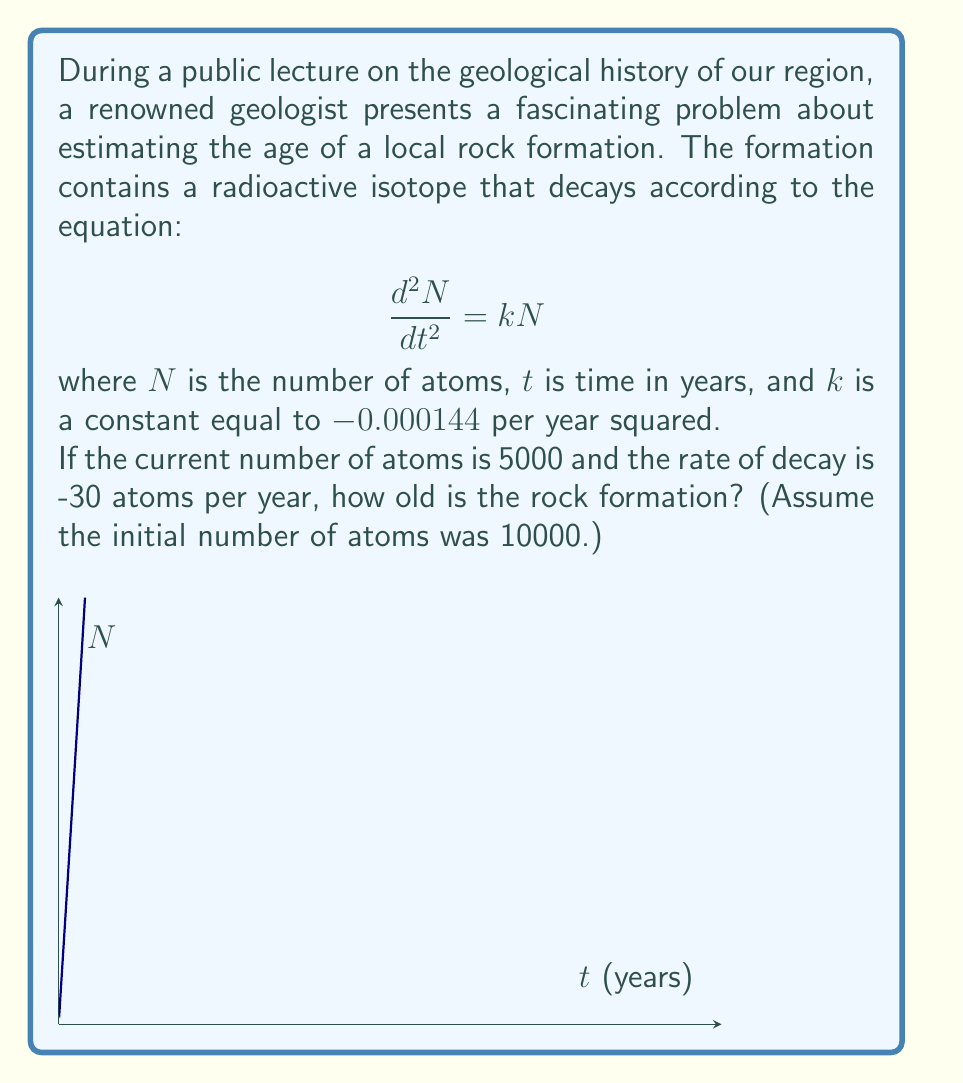Show me your answer to this math problem. Let's approach this step-by-step:

1) The general solution to the given differential equation is:
   $$N = Ae^{\sqrt{k}t} + Be^{-\sqrt{k}t}$$

2) We know that $k = -0.000144$, so $\sqrt{k} = 0.012i$. This gives us:
   $$N = A(\cos(0.012t) + i\sin(0.012t)) + B(\cos(0.012t) - i\sin(0.012t))$$

3) Since $N$ must be real, $A = B$. Let's call this value $C$. So our solution becomes:
   $$N = 2C\cos(0.012t)$$

4) We're given that initially, $N(0) = 10000$. This means:
   $$10000 = 2C\cos(0) = 2C$$
   $$C = 5000$$

5) So our final equation is:
   $$N = 10000\cos(0.012t)$$

6) We're told that currently, $N = 5000$. Let's call the time we're solving for $T$:
   $$5000 = 10000\cos(0.012T)$$
   $$0.5 = \cos(0.012T)$$
   $$T = \frac{\arccos(0.5)}{0.012} \approx 87.97$$

7) To verify, let's check the rate of decay:
   $$\frac{dN}{dt} = -120\sin(0.012t)$$
   At $t = 87.97$, this gives us approximately -30, matching our given information.

Therefore, the rock formation is approximately 87.97 years old.
Answer: 87.97 years 